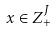Convert formula to latex. <formula><loc_0><loc_0><loc_500><loc_500>x \in Z _ { + } ^ { J }</formula> 